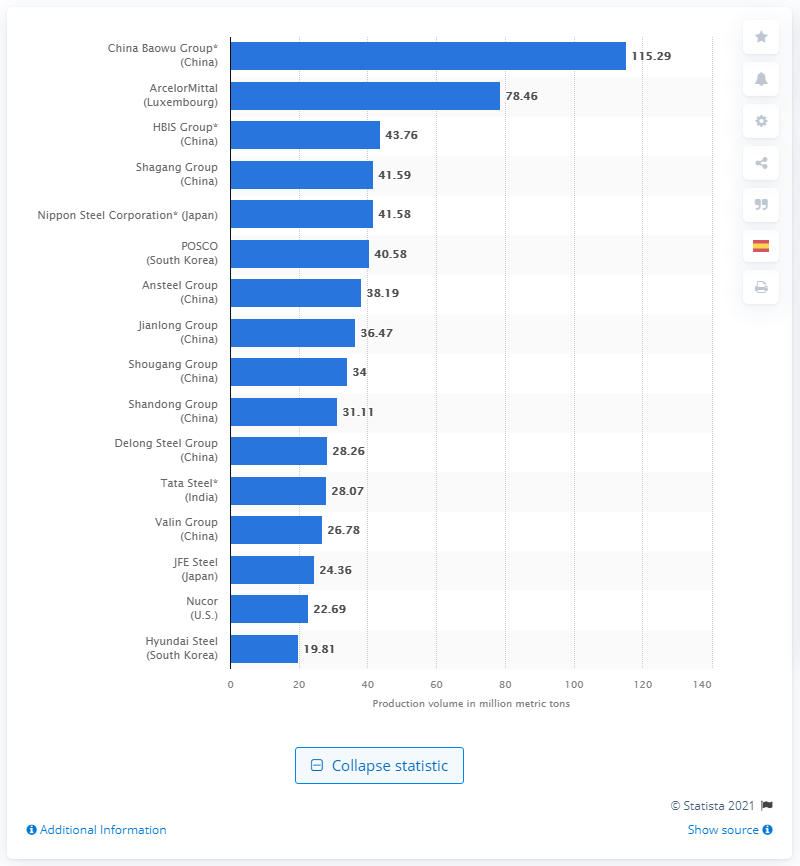Outline some significant characteristics in this image. In 2020, China Baowu Group produced a total of 115,290 metric tons of crude steel. 